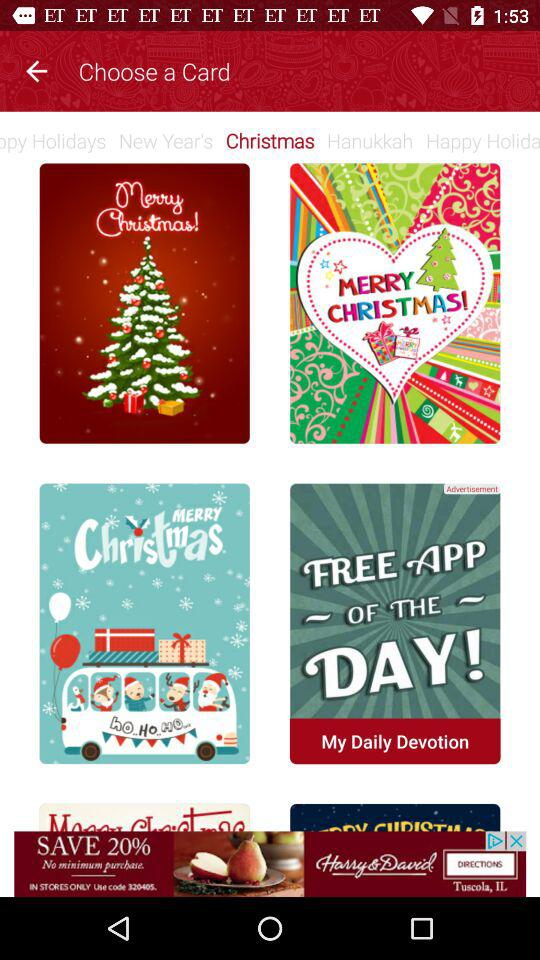Which is the selected tab? The selected tab is "Christmas". 